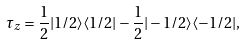Convert formula to latex. <formula><loc_0><loc_0><loc_500><loc_500>\tau _ { z } = \frac { 1 } { 2 } | 1 / 2 \rangle \langle 1 / 2 | - \frac { 1 } { 2 } | - 1 / 2 \rangle \langle - 1 / 2 | ,</formula> 